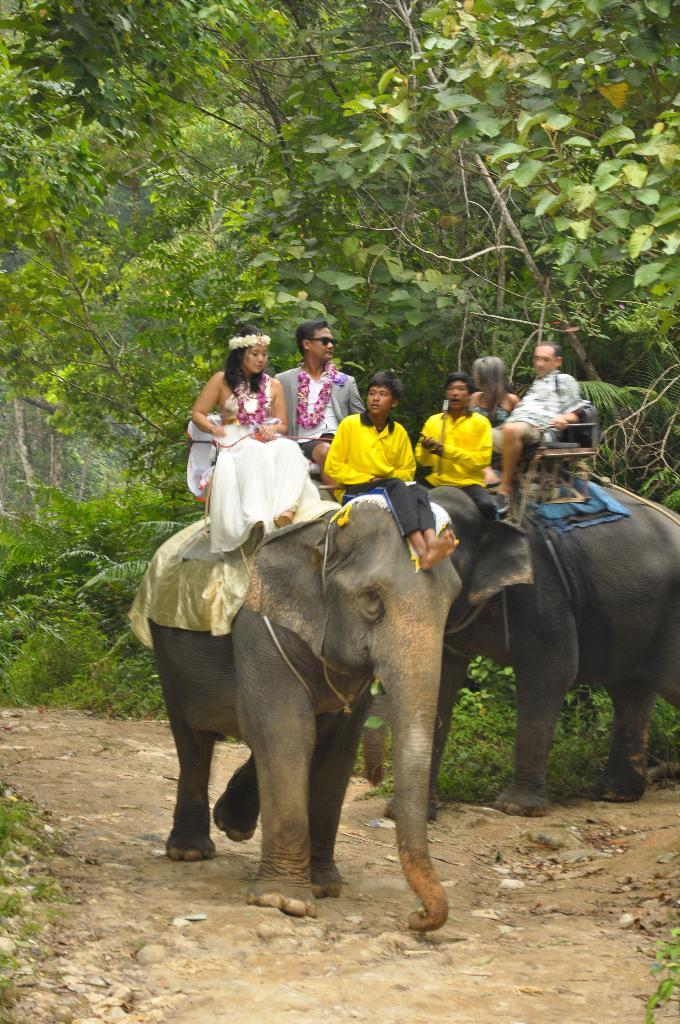What type of natural environment is visible in the background of the image? There are trees and plants in the background of the image, suggesting a forest setting. What are the persons in the image doing? The persons in the image are sitting on elephants. How many ladybugs can be seen participating in the feast in the image? There are no ladybugs or feast depicted in the image; it features persons sitting on elephants in a forest setting. 